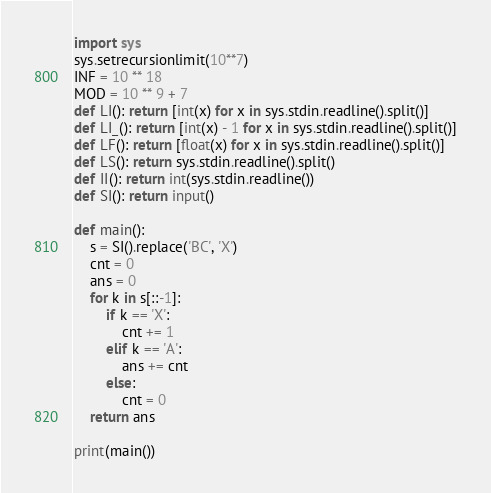<code> <loc_0><loc_0><loc_500><loc_500><_Python_>import sys
sys.setrecursionlimit(10**7)
INF = 10 ** 18
MOD = 10 ** 9 + 7
def LI(): return [int(x) for x in sys.stdin.readline().split()]
def LI_(): return [int(x) - 1 for x in sys.stdin.readline().split()]
def LF(): return [float(x) for x in sys.stdin.readline().split()]
def LS(): return sys.stdin.readline().split()
def II(): return int(sys.stdin.readline())
def SI(): return input()

def main():
    s = SI().replace('BC', 'X')
    cnt = 0
    ans = 0
    for k in s[::-1]:
        if k == 'X':
            cnt += 1
        elif k == 'A':
            ans += cnt
        else:
            cnt = 0
    return ans

print(main())</code> 